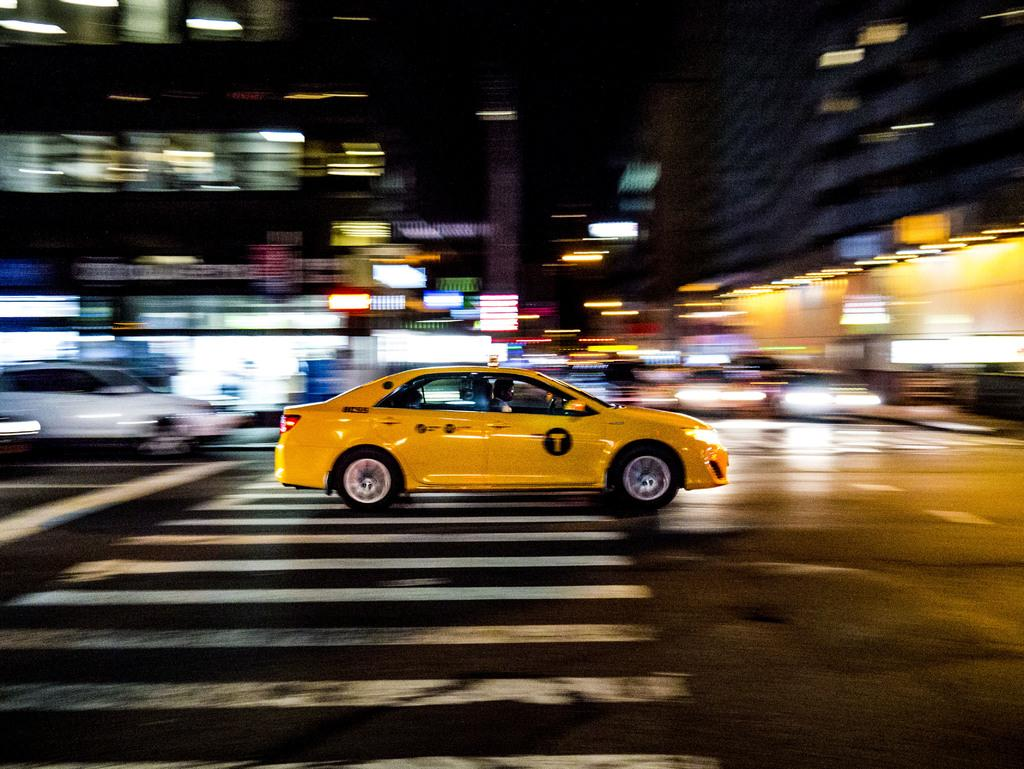<image>
Give a short and clear explanation of the subsequent image. a yellow T taxi driving down an otherwise blurred street 